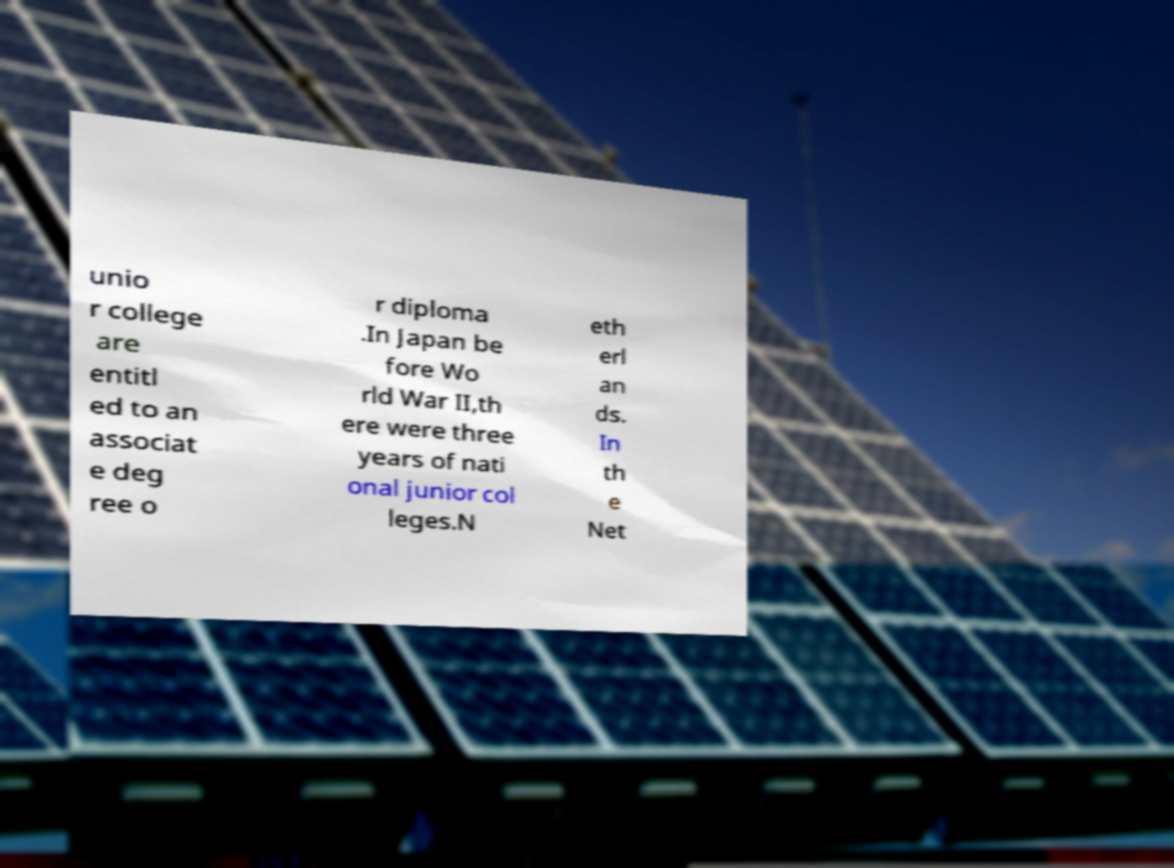Could you extract and type out the text from this image? unio r college are entitl ed to an associat e deg ree o r diploma .In Japan be fore Wo rld War II,th ere were three years of nati onal junior col leges.N eth erl an ds. In th e Net 